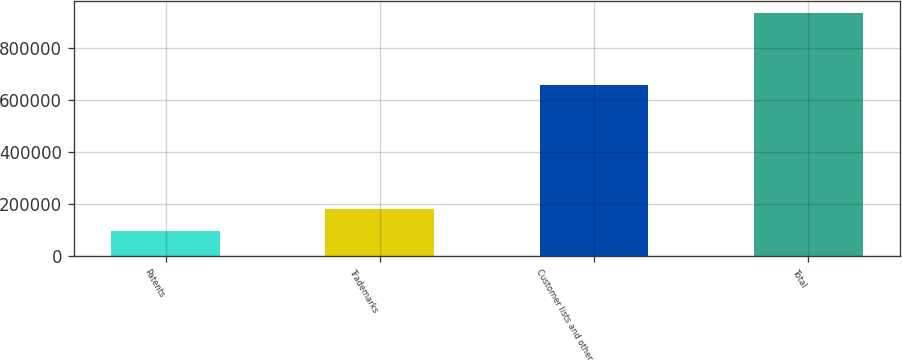<chart> <loc_0><loc_0><loc_500><loc_500><bar_chart><fcel>Patents<fcel>Trademarks<fcel>Customer lists and other<fcel>Total<nl><fcel>95961<fcel>179532<fcel>656552<fcel>931669<nl></chart> 